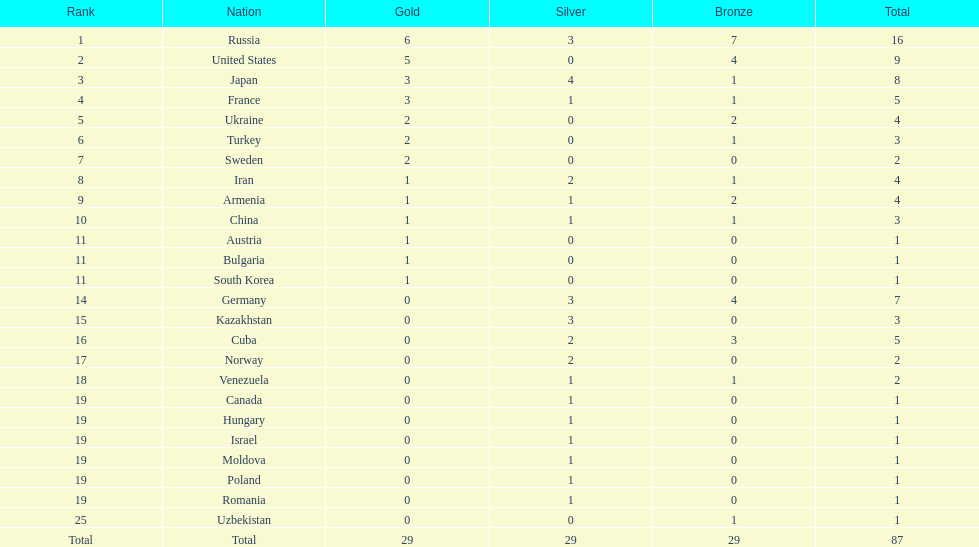Which nation has one gold medal but zero in both silver and bronze? Austria. 